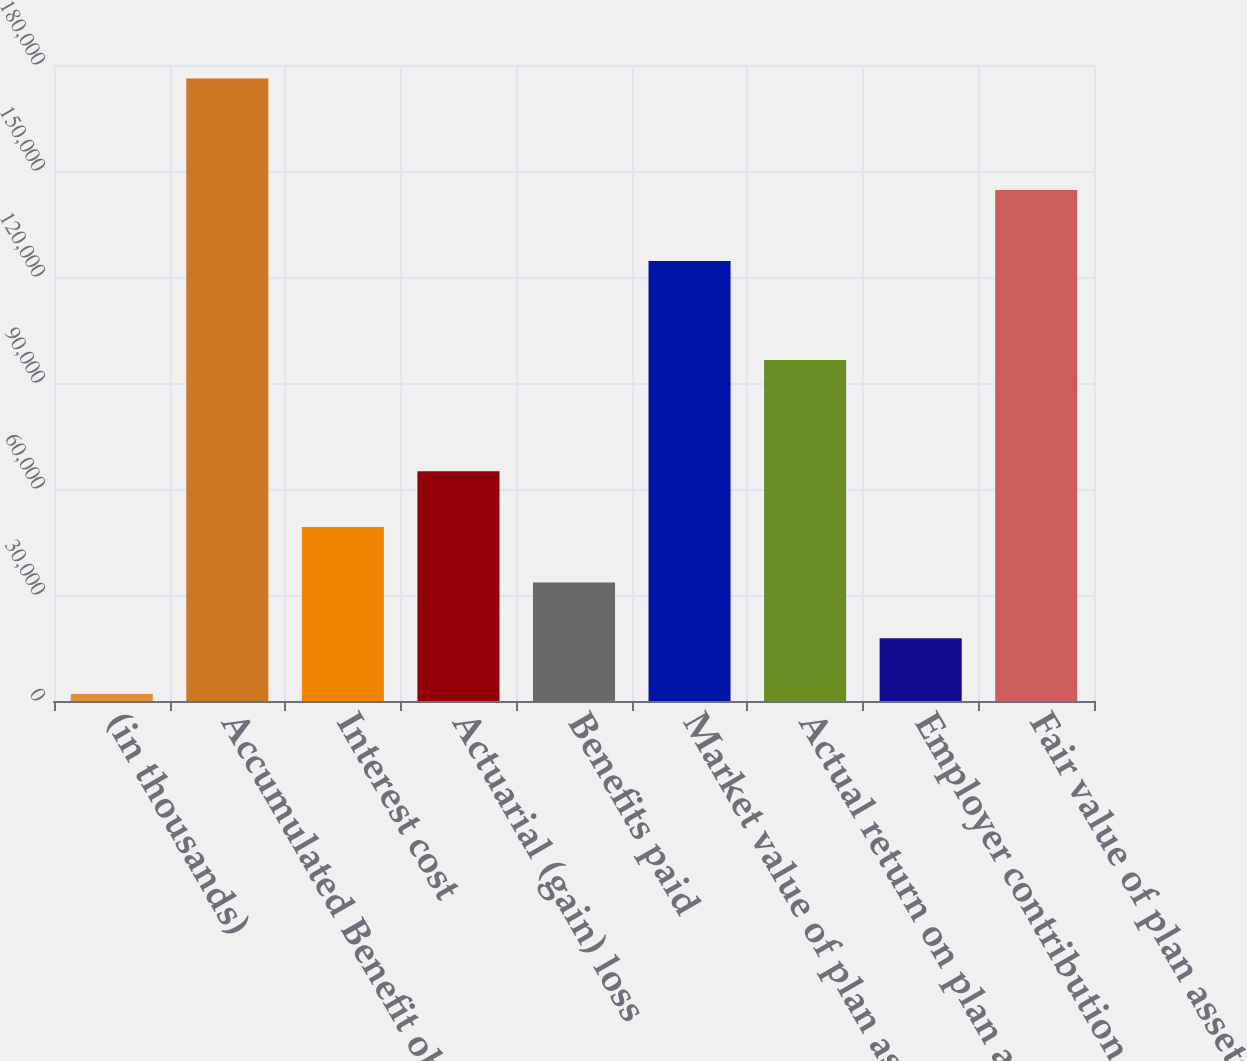<chart> <loc_0><loc_0><loc_500><loc_500><bar_chart><fcel>(in thousands)<fcel>Accumulated Benefit obligation<fcel>Interest cost<fcel>Actuarial (gain) loss<fcel>Benefits paid<fcel>Market value of plan assets at<fcel>Actual return on plan assets<fcel>Employer contribution<fcel>Fair value of plan assets at<nl><fcel>2009<fcel>176150<fcel>49268<fcel>65021<fcel>33515<fcel>124519<fcel>96527<fcel>17762<fcel>144644<nl></chart> 